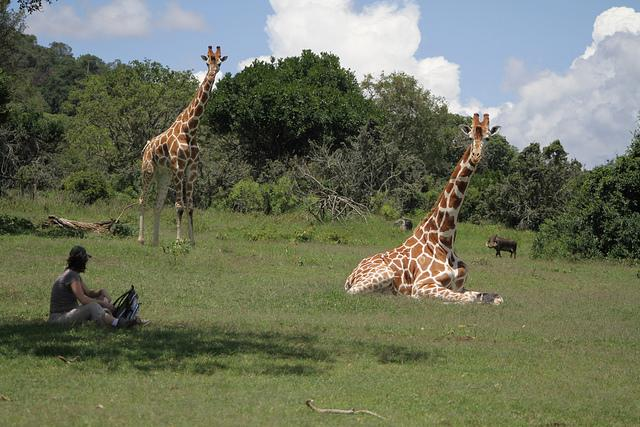Where is the person in? africa 